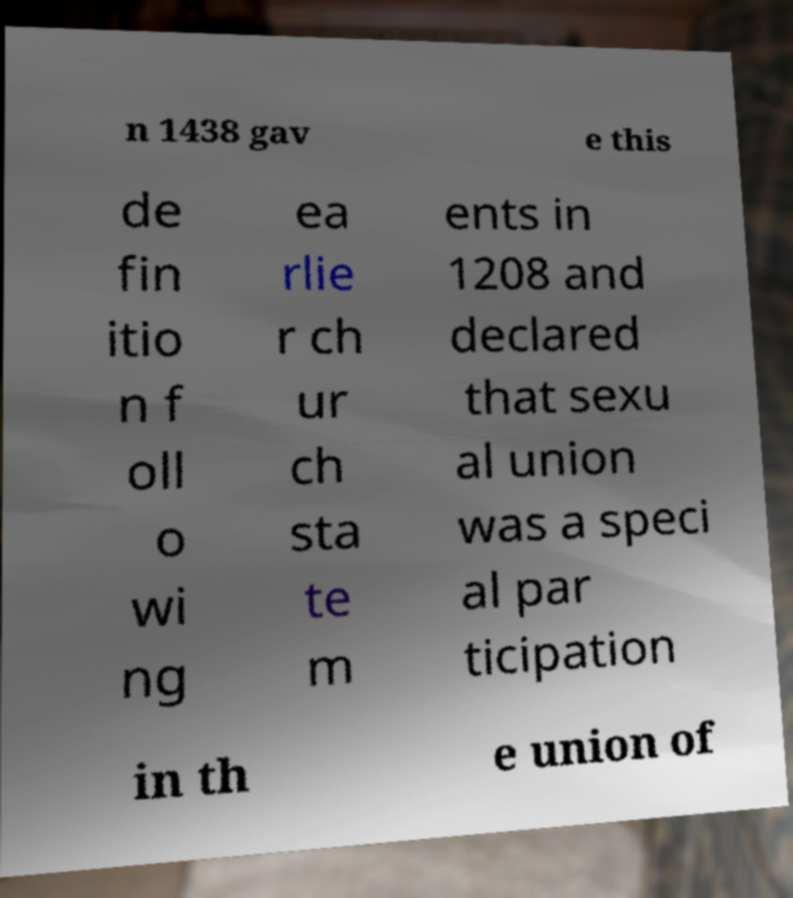Can you accurately transcribe the text from the provided image for me? n 1438 gav e this de fin itio n f oll o wi ng ea rlie r ch ur ch sta te m ents in 1208 and declared that sexu al union was a speci al par ticipation in th e union of 